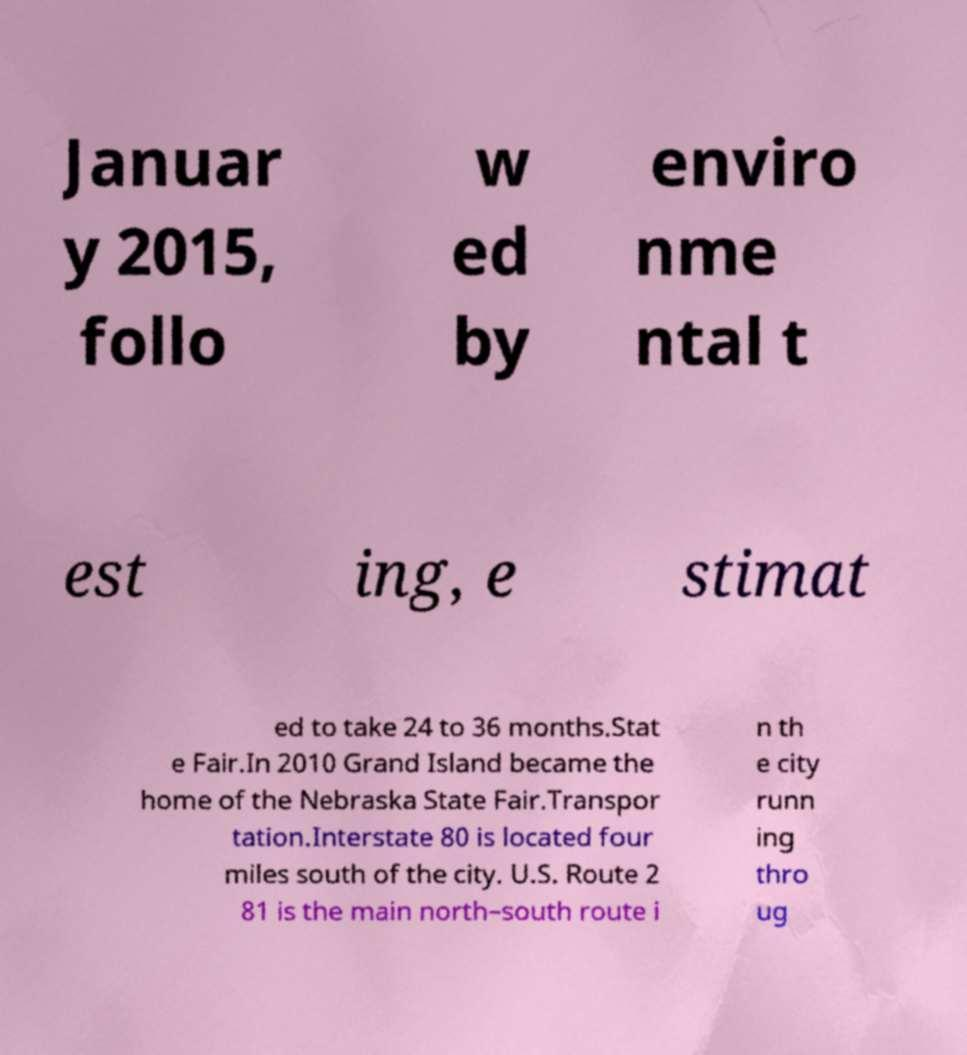Could you assist in decoding the text presented in this image and type it out clearly? Januar y 2015, follo w ed by enviro nme ntal t est ing, e stimat ed to take 24 to 36 months.Stat e Fair.In 2010 Grand Island became the home of the Nebraska State Fair.Transpor tation.Interstate 80 is located four miles south of the city. U.S. Route 2 81 is the main north–south route i n th e city runn ing thro ug 